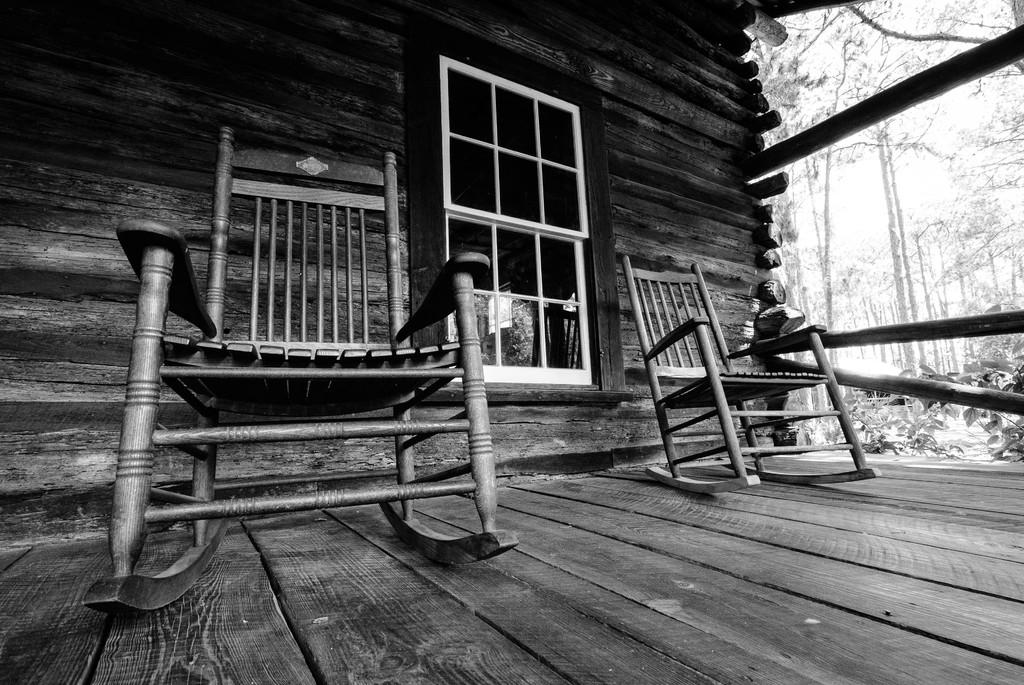What type of picture is in the image? The image contains a black and white picture. What type of flooring is visible in the picture? The wooden floor is visible in the picture. How many chairs are in the picture? There are two chairs in the picture. What type of structure is present in the picture? The house is present in the picture. What architectural feature is in the picture? There is a window in the picture. What can be seen in the background of the picture? Trees and the sky are visible in the background of the picture. What type of meat is being tested in the image? There is no meat or testing present in the image; it contains a black and white picture of a house with a wooden floor, two chairs, a window, trees, and the sky in the background. 